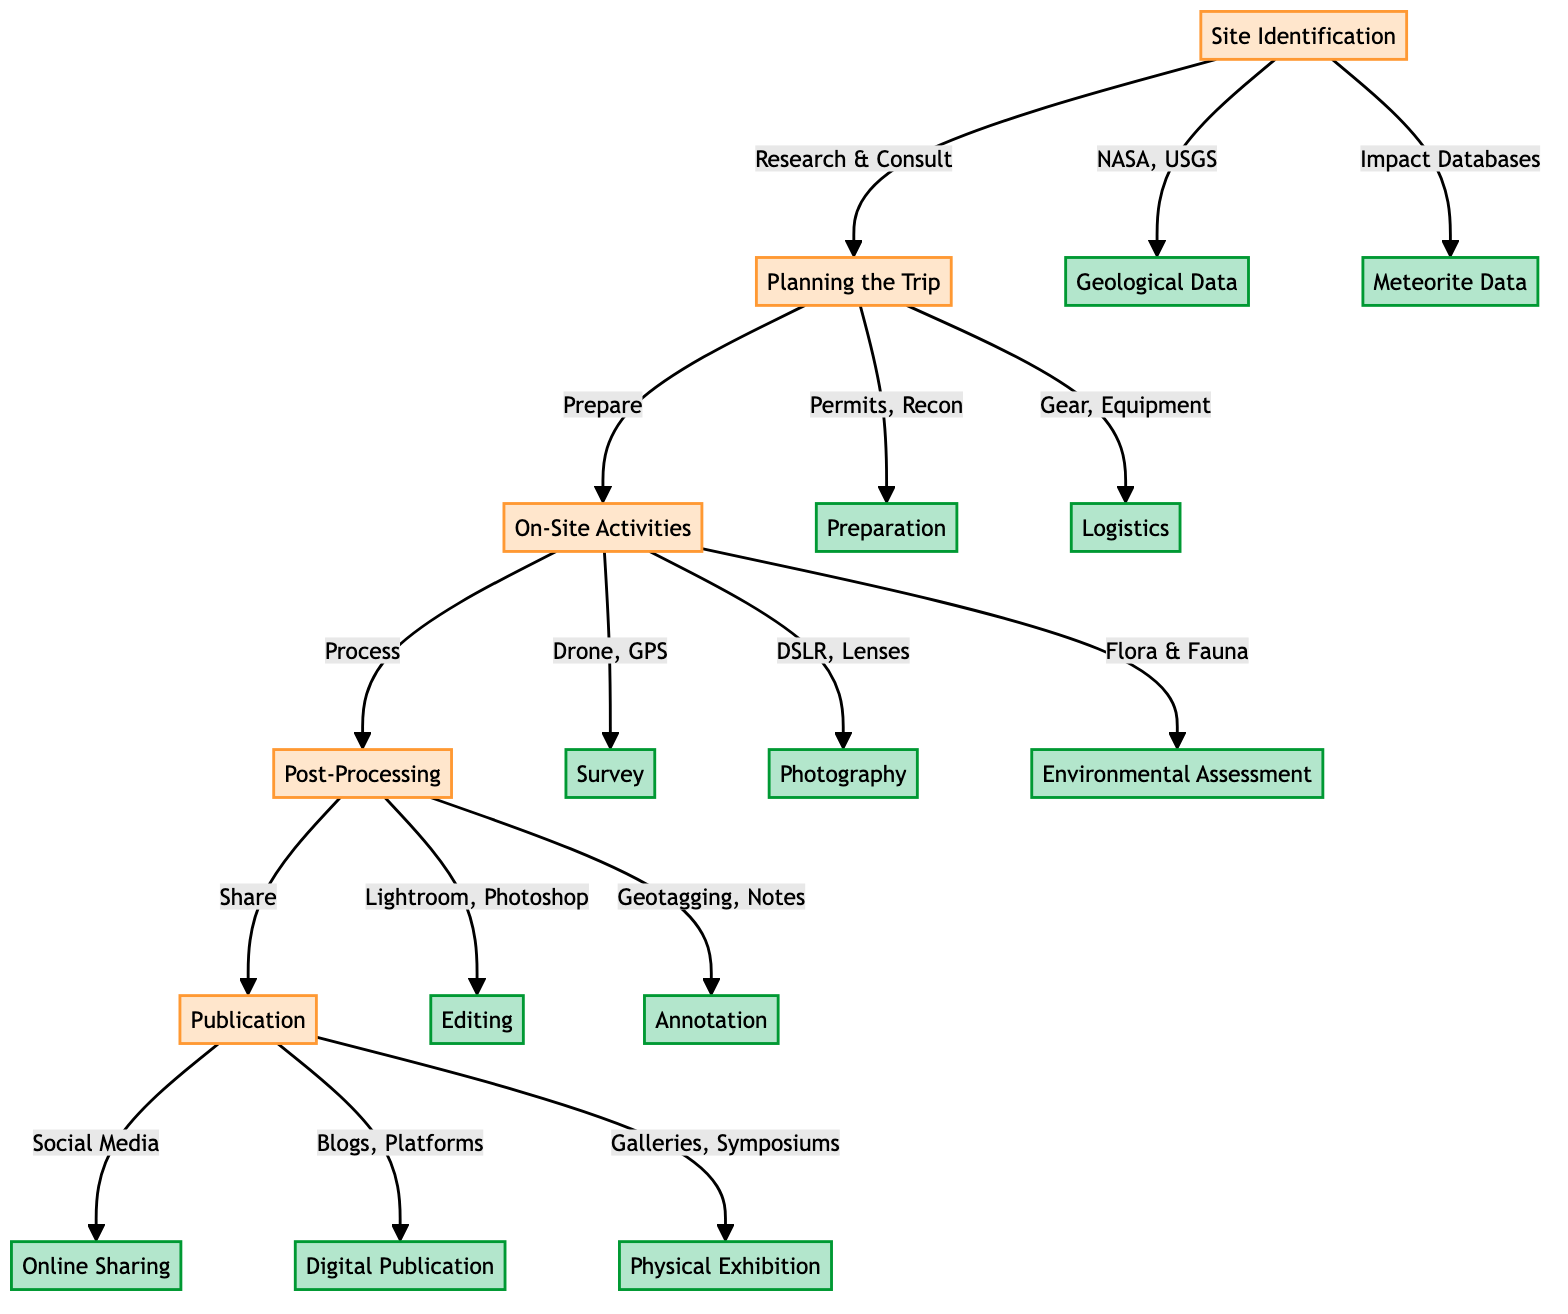What are the two main activities in the Site Identification phase? The diagram lists two main activities under Site Identification: "Research Geological Data" and "Consult Meteorite Impact Databases." Thus, these are the key tasks in that phase.
Answer: Research Geological Data, Consult Meteorite Impact Databases How many nodes are there in the On-Site Activities phase? In checking the On-Site Activities node, it branches out to three sub-activities: "Initial Survey," "Photographic Documentation," and "Environmental Impact Assessment." This totals to three nodes.
Answer: 3 What is the first step in the Post-Processing phase? According to the diagram, the first action listed under Post-Processing is "Photo Editing," which initiates the entire process of editing photographs.
Answer: Photo Editing Which phase follows Planning the Trip? The diagram indicates a flow from Planning the Trip directly to On-Site Activities. Hence, On-Site Activities is the phase that follows.
Answer: On-Site Activities What are the methods used in the Environmental Impact Assessment activity? The diagram clearly lists "Flora and Fauna Documentation" and "Minimizing Disturbance" as the methods involved in Environmental Impact Assessment.
Answer: Flora and Fauna Documentation, Minimizing Disturbance How many distinct routes are there from the On-Site Activities phase to the Post-Processing phase? The On-Site Activities phase branches into three distinct activities, all of which connect directly to the Post-Processing phase. Therefore, there are three routes from this phase to the next.
Answer: 3 What is the common output for the Publication phase? The outputs of the Publication phase include three components: "Social Media," "Photography Blogs," and "Photo Exhibition." All these represent the ways data is shared post-processing.
Answer: Social Media, Photography Blogs, Photo Exhibition What tools are mentioned for Photo Editing? In the Post-Processing phase, the tools provided for Photo Editing are "Adobe Lightroom" and "Photoshop," making them essential for photo enhancement.
Answer: Adobe Lightroom, Photoshop 